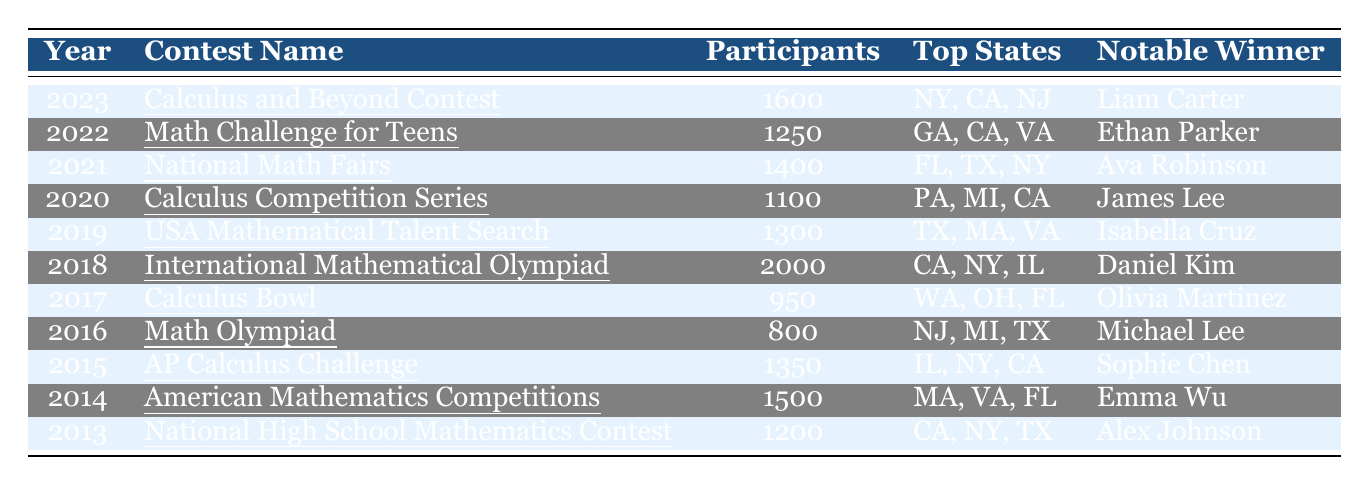What was the participation rate in the year 2021? The table indicates that the participation rate for the year 2021 under the "National Math Fairs" contest was 1400.
Answer: 1400 Which contest in 2018 had the highest participation rate? The table shows that the "International Mathematical Olympiad" in 2018 had the highest participation rate of 2000 among all contests listed from 2013 to 2023.
Answer: 2000 What are the top three states in terms of participation for the "Calculus and Beyond Contest"? The table lists the top three states for the "Calculus and Beyond Contest" in 2023 as New York, California, and New Jersey.
Answer: New York, California, New Jersey Which notable winner participated in 2016, and how many participants were there in that year? According to the table, Michael Lee was the notable winner in 2016 when the "Math Olympiad" had 800 participants.
Answer: Michael Lee, 800 What was the average participation rate over the last decade? The participation rates are: 1200, 1500, 1350, 800, 950, 2000, 1300, 1100, 1400, 1250, 1600. The total is 15,600, and there are 11 years, so the average is 15,600 / 11 ≈ 1418.18.
Answer: Approximately 1418.18 Did the participation rate increase from 2017 to 2023? The participation rate in 2017 was 950, and in 2023 it was 1600, indicating an increase. Therefore, the statement is true.
Answer: Yes Which year had the lowest participation rate and what was the value? By examining the table, the lowest participation rate appears to be in 2016 with 800 participants in the "Math Olympiad."
Answer: 800 How many more participants were there in 2023 compared to 2019? In 2023, there were 1600 participants, and in 2019, there were 1300. The difference is 1600 - 1300 = 300 more participants.
Answer: 300 What is the total number of participants across all contests from 2013 to 2023? Summing the participation rates: 1200 + 1500 + 1350 + 800 + 950 + 2000 + 1300 + 1100 + 1400 + 1250 + 1600 = 15,600 participants in total.
Answer: 15600 Which contest had a participation rate below 1000 and what was its name? Reviewing the table, the "Calculus Bowl" in 2017 had a participation rate of 950, which is below 1000.
Answer: Calculus Bowl In how many of the listed years did the participation exceed 1500? Looking at the table, the years where participation exceeded 1500 are 2014 (1500), 2018 (2000), and 2023 (1600), which totals 3 years.
Answer: 3 